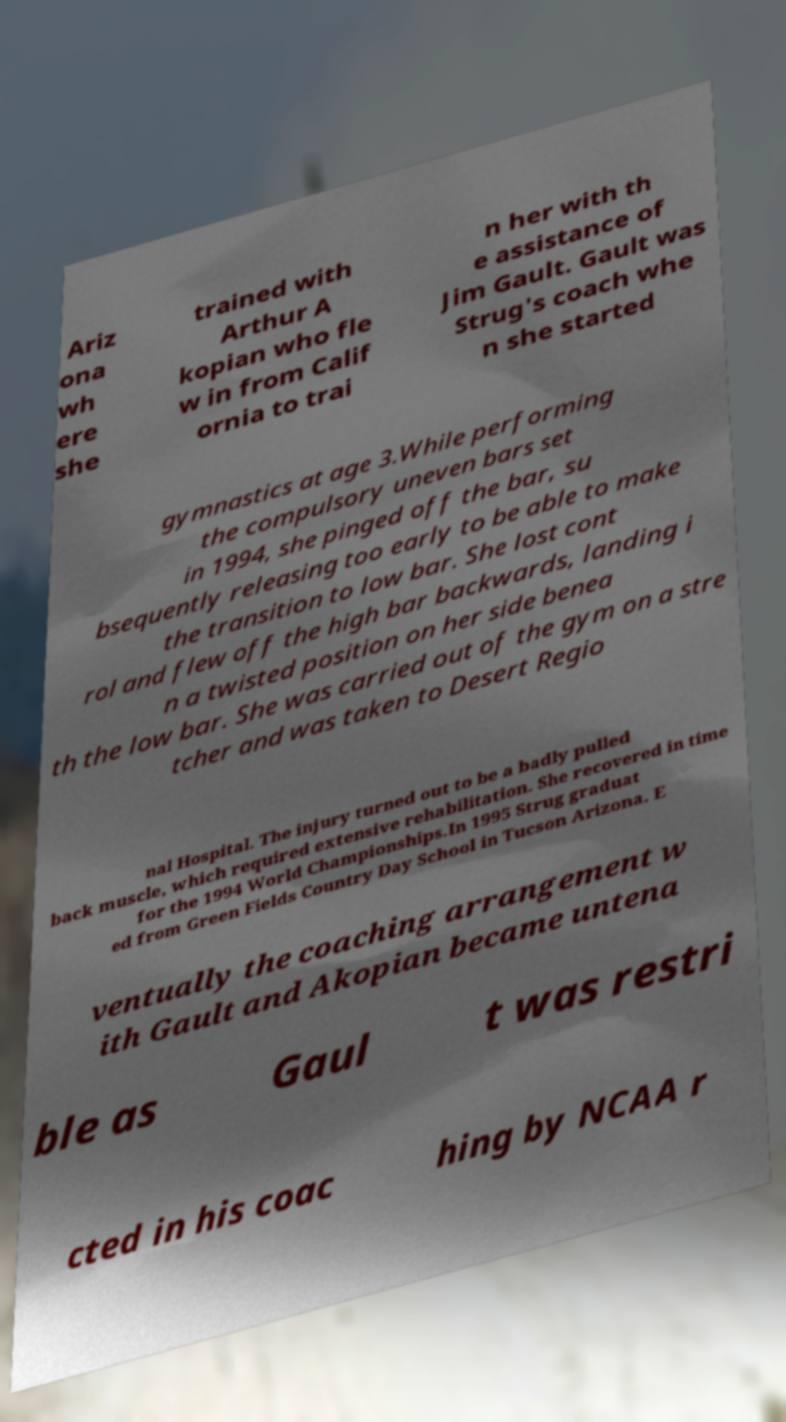What messages or text are displayed in this image? I need them in a readable, typed format. Ariz ona wh ere she trained with Arthur A kopian who fle w in from Calif ornia to trai n her with th e assistance of Jim Gault. Gault was Strug's coach whe n she started gymnastics at age 3.While performing the compulsory uneven bars set in 1994, she pinged off the bar, su bsequently releasing too early to be able to make the transition to low bar. She lost cont rol and flew off the high bar backwards, landing i n a twisted position on her side benea th the low bar. She was carried out of the gym on a stre tcher and was taken to Desert Regio nal Hospital. The injury turned out to be a badly pulled back muscle, which required extensive rehabilitation. She recovered in time for the 1994 World Championships.In 1995 Strug graduat ed from Green Fields Country Day School in Tucson Arizona. E ventually the coaching arrangement w ith Gault and Akopian became untena ble as Gaul t was restri cted in his coac hing by NCAA r 